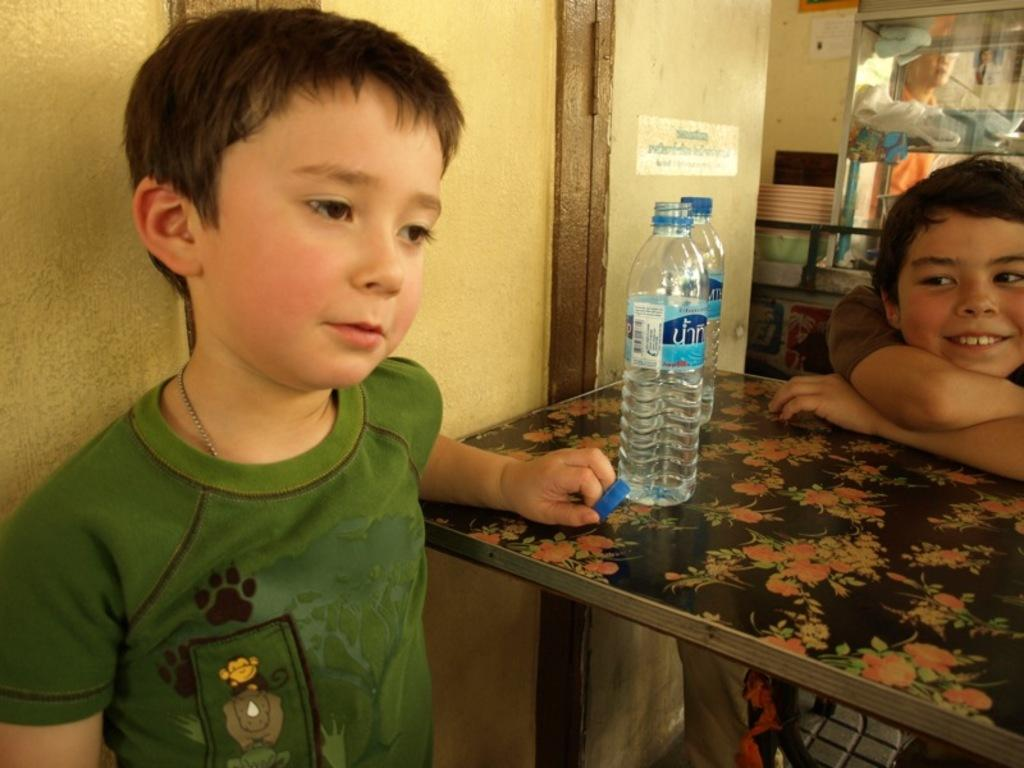How many boys are present in the image? There are 2 boys in the image. Where are the boys positioned in relation to each other? The boys are positioned on either side of a table. What items can be seen on the table? There are 2 water bottles on the table. What can be seen in the background of the image? There is a wall and a person visible in the background of the image. What type of sand can be seen on the table in the image? There is no sand present on the table or in the image. 